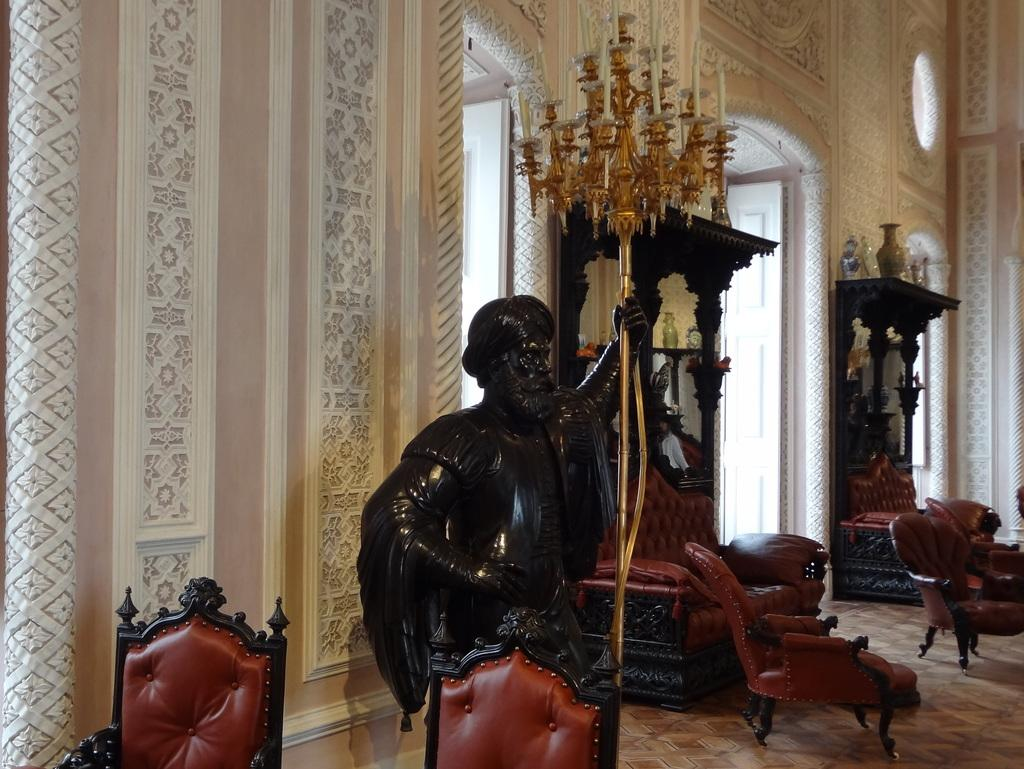What is the main subject in the center of the image? There is a statue in the center of the image. What type of furniture can be seen at the bottom of the image? There are chairs in the bottom of the image. What can be seen in the distance behind the statue? There is a building in the background of the image. Can you describe any other objects visible in the background? There are some unspecified objects in the background of the image. What type of trade is happening between the chickens in the image? There are no chickens present in the image, so it is not possible to answer that question. 